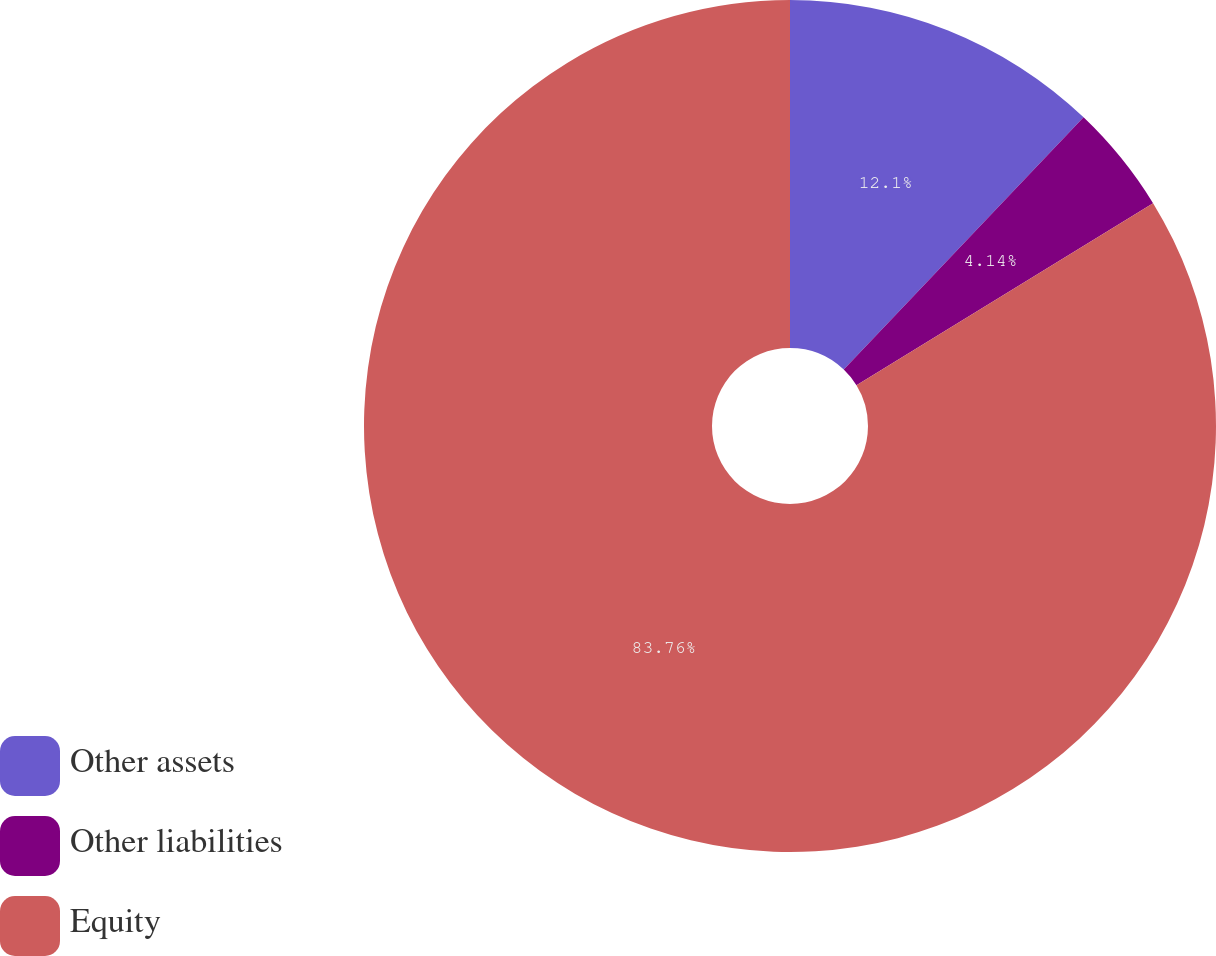Convert chart to OTSL. <chart><loc_0><loc_0><loc_500><loc_500><pie_chart><fcel>Other assets<fcel>Other liabilities<fcel>Equity<nl><fcel>12.1%<fcel>4.14%<fcel>83.76%<nl></chart> 